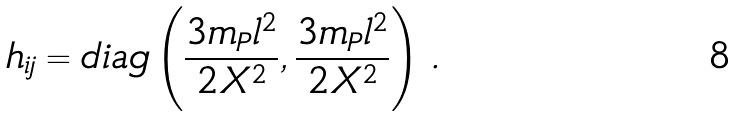Convert formula to latex. <formula><loc_0><loc_0><loc_500><loc_500>h _ { i j } = d i a g \left ( \frac { 3 m _ { P } l ^ { 2 } } { 2 X ^ { 2 } } , \frac { 3 m _ { P } l ^ { 2 } } { 2 X ^ { 2 } } \right ) \, .</formula> 